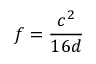<formula> <loc_0><loc_0><loc_500><loc_500>f = { \frac { c ^ { 2 } } { 1 6 d } }</formula> 